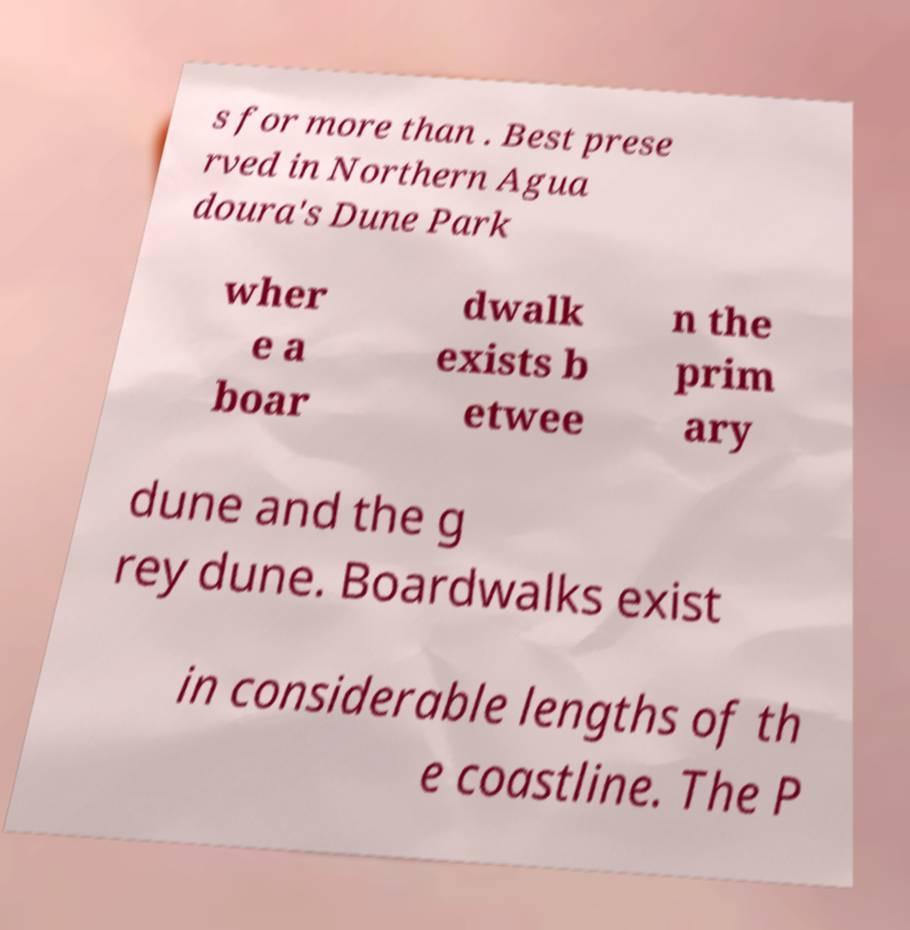Please read and relay the text visible in this image. What does it say? s for more than . Best prese rved in Northern Agua doura's Dune Park wher e a boar dwalk exists b etwee n the prim ary dune and the g rey dune. Boardwalks exist in considerable lengths of th e coastline. The P 